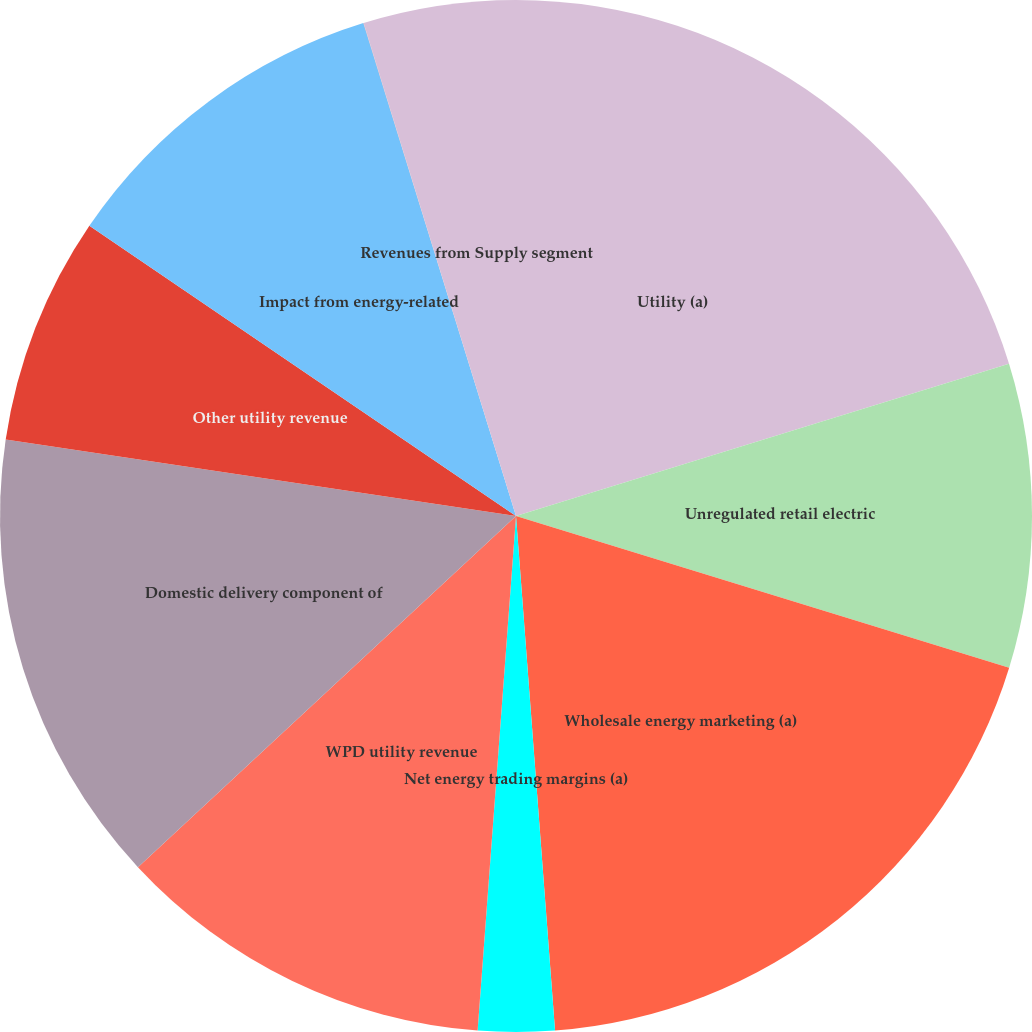<chart> <loc_0><loc_0><loc_500><loc_500><pie_chart><fcel>Utility (a)<fcel>Unregulated retail electric<fcel>Wholesale energy marketing (a)<fcel>Net energy trading margins (a)<fcel>WPD utility revenue<fcel>Domestic delivery component of<fcel>Other utility revenue<fcel>Impact from energy-related<fcel>Gains from sale of emission<fcel>Revenues from Supply segment<nl><fcel>20.23%<fcel>9.52%<fcel>19.04%<fcel>2.39%<fcel>11.9%<fcel>14.28%<fcel>7.14%<fcel>10.71%<fcel>0.01%<fcel>4.77%<nl></chart> 